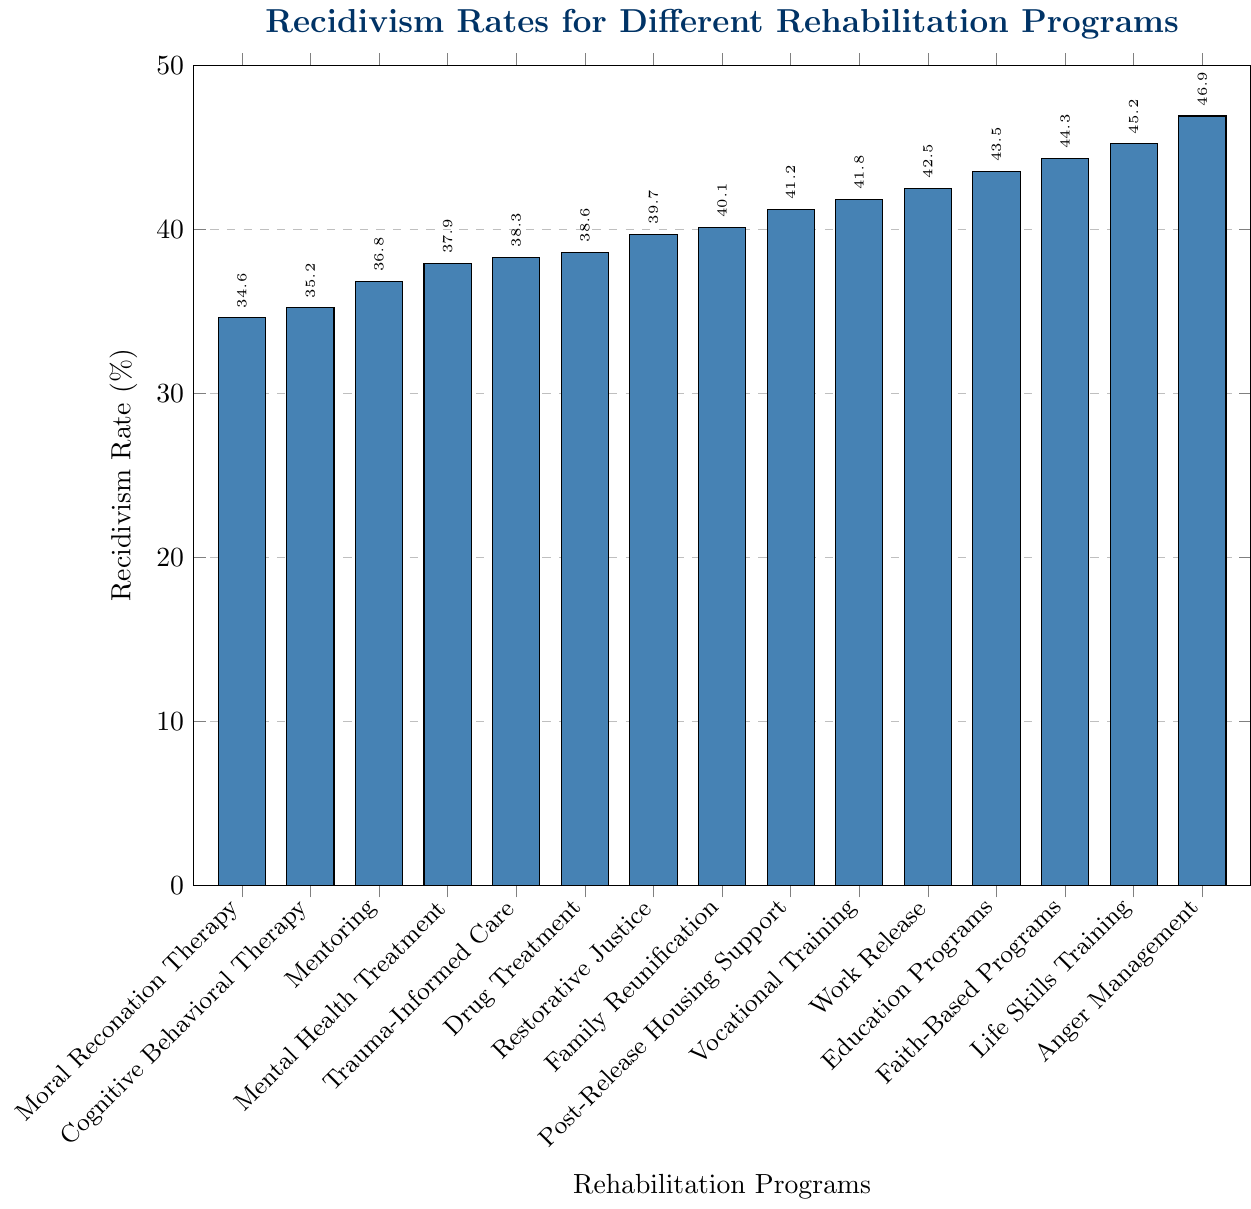What is the recidivism rate for Moral Reconation Therapy? Look at the height of the bar labeled "Moral Reconation Therapy," which shows the recidivism rate for this program.
Answer: 34.6% Which rehabilitation program has the highest recidivism rate? Compare the heights of all the bars and identify the tallest one, which corresponds to "Anger Management."
Answer: Anger Management Which program has a lower recidivism rate: Drug Treatment or Faith-Based Programs? Compare the heights of the bars labeled "Drug Treatment" (38.6%) and "Faith-Based Programs" (44.3%).
Answer: Drug Treatment What is the difference in recidivism rates between Life Skills Training and Cognitive Behavioral Therapy? Subtract the recidivism rate of Cognitive Behavioral Therapy (35.2%) from that of Life Skills Training (45.2%).
Answer: 10% How many programs have a recidivism rate higher than 40%? Count the bars with heights representing recidivism rates greater than 40%: Vocational Training, Work Release, Education Programs, Faith-Based Programs, Life Skills Training, and Anger Management.
Answer: 6 What is the average recidivism rate for Cognitive Behavioral Therapy, Vocational Training, and Drug Treatment? Sum the recidivism rates of Cognitive Behavioral Therapy (35.2%), Vocational Training (41.8%), and Drug Treatment (38.6%) and then divide by 3. Calculation: (35.2 + 41.8 + 38.6) / 3 = 115.6 / 3.
Answer: 38.53% Which has a smaller recidivism rate: Restorative Justice or Post-Release Housing Support? Compare the recidivism rates of Restorative Justice (39.7%) and Post-Release Housing Support (41.2%).
Answer: Restorative Justice What is the median recidivism rate of all programs? Arrange the recidivism rates in ascending order and find the middle value since there are 15 programs. The median is the 8th value in the sorted list.
Answer: 39.7% How much higher is the recidivism rate for Education Programs compared to Mentoring? Subtract the recidivism rate of Mentoring (36.8%) from that of Education Programs (43.5%).
Answer: 6.7% Among the programs listed, which three have the lowest recidivism rates? Identify the three shortest bars, which correspond to "Moral Reconation Therapy," "Cognitive Behavioral Therapy," and "Mentoring."
Answer: Moral Reconation Therapy, Cognitive Behavioral Therapy, Mentoring 